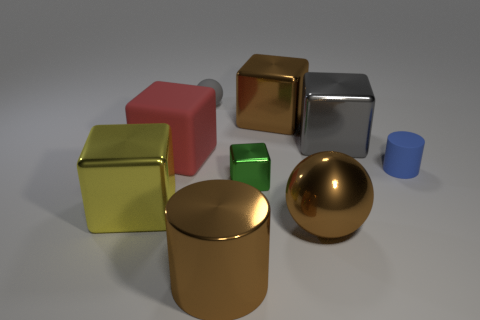Subtract 2 cubes. How many cubes are left? 3 Subtract all red cubes. How many cubes are left? 4 Subtract all big red cubes. How many cubes are left? 4 Add 1 tiny cyan rubber spheres. How many objects exist? 10 Subtract all cubes. How many objects are left? 4 Add 3 brown things. How many brown things are left? 6 Add 9 big cylinders. How many big cylinders exist? 10 Subtract 0 green spheres. How many objects are left? 9 Subtract all cylinders. Subtract all brown metal balls. How many objects are left? 6 